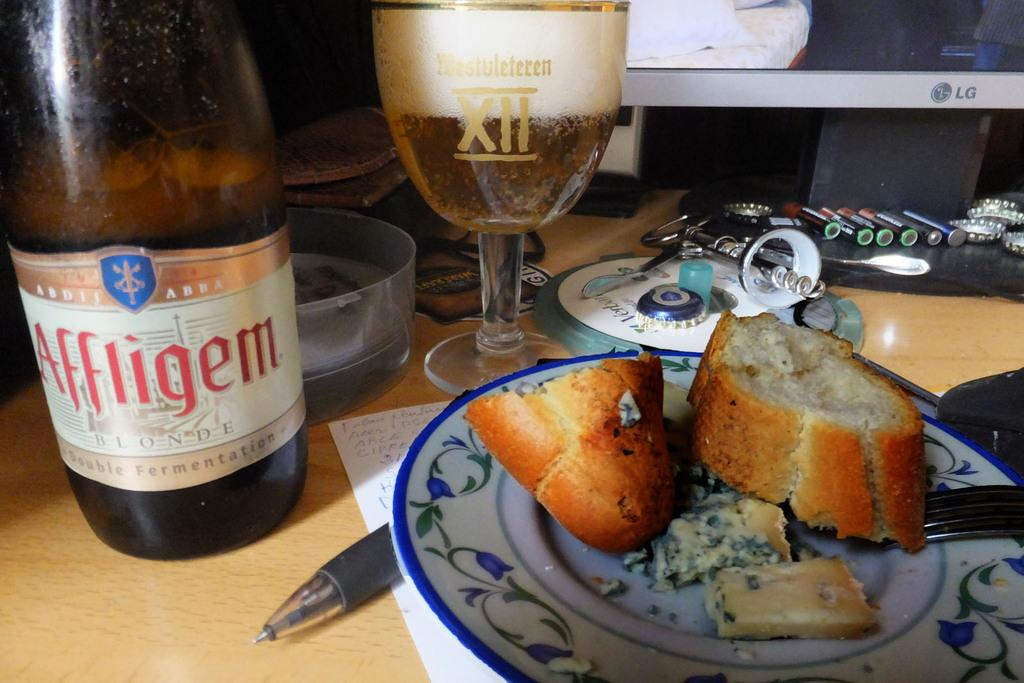Provide a one-sentence caption for the provided image. Bread next to a large bottle of Affligem. 